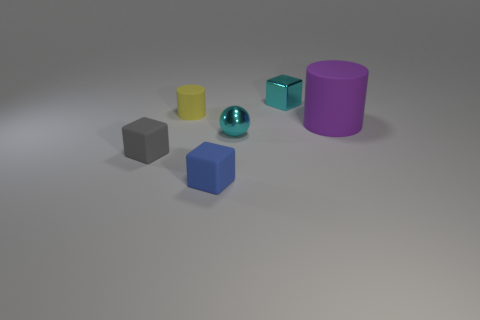What shape is the cyan metal object that is behind the cyan metal object that is in front of the big cylinder?
Your response must be concise. Cube. There is a small cyan metallic block; how many small shiny balls are right of it?
Ensure brevity in your answer.  0. There is a large object that is the same material as the yellow cylinder; what color is it?
Keep it short and to the point. Purple. There is a gray cube; is its size the same as the cyan sphere left of the purple matte object?
Offer a terse response. Yes. There is a cyan thing that is in front of the cube that is to the right of the small rubber thing to the right of the small yellow cylinder; what is its size?
Your response must be concise. Small. How many metal things are small brown objects or small cyan spheres?
Your answer should be compact. 1. There is a small cube behind the big matte thing; what color is it?
Offer a terse response. Cyan. What is the shape of the blue object that is the same size as the yellow object?
Keep it short and to the point. Cube. Does the tiny sphere have the same color as the block on the right side of the tiny blue matte thing?
Ensure brevity in your answer.  Yes. What number of objects are objects that are in front of the cyan shiny cube or tiny objects that are left of the blue cube?
Give a very brief answer. 5. 